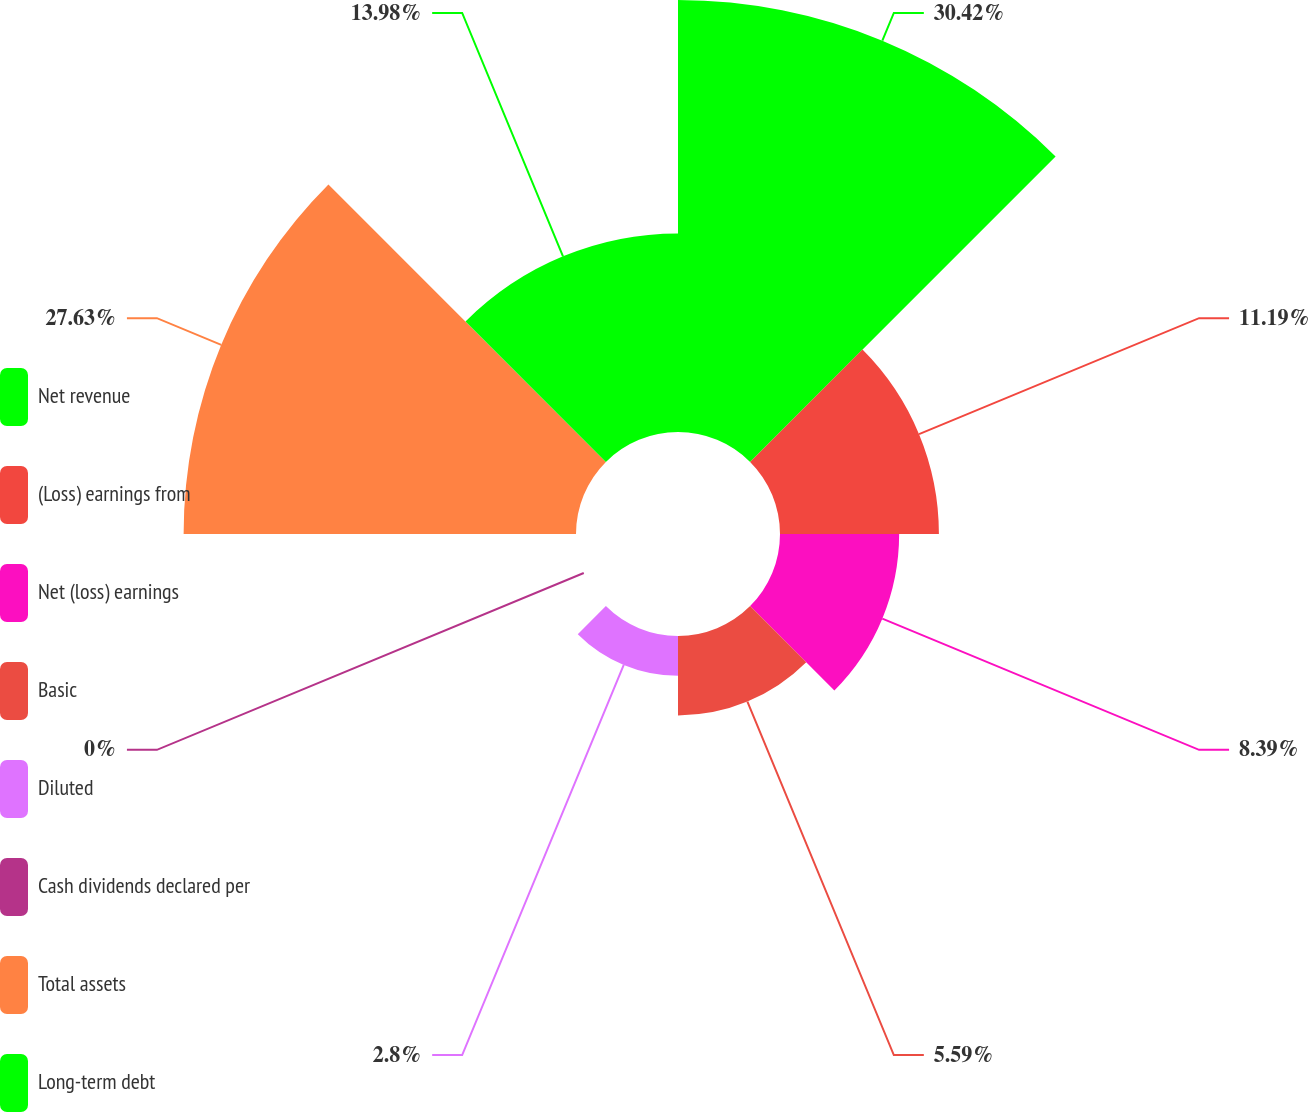Convert chart. <chart><loc_0><loc_0><loc_500><loc_500><pie_chart><fcel>Net revenue<fcel>(Loss) earnings from<fcel>Net (loss) earnings<fcel>Basic<fcel>Diluted<fcel>Cash dividends declared per<fcel>Total assets<fcel>Long-term debt<nl><fcel>30.42%<fcel>11.19%<fcel>8.39%<fcel>5.59%<fcel>2.8%<fcel>0.0%<fcel>27.63%<fcel>13.98%<nl></chart> 